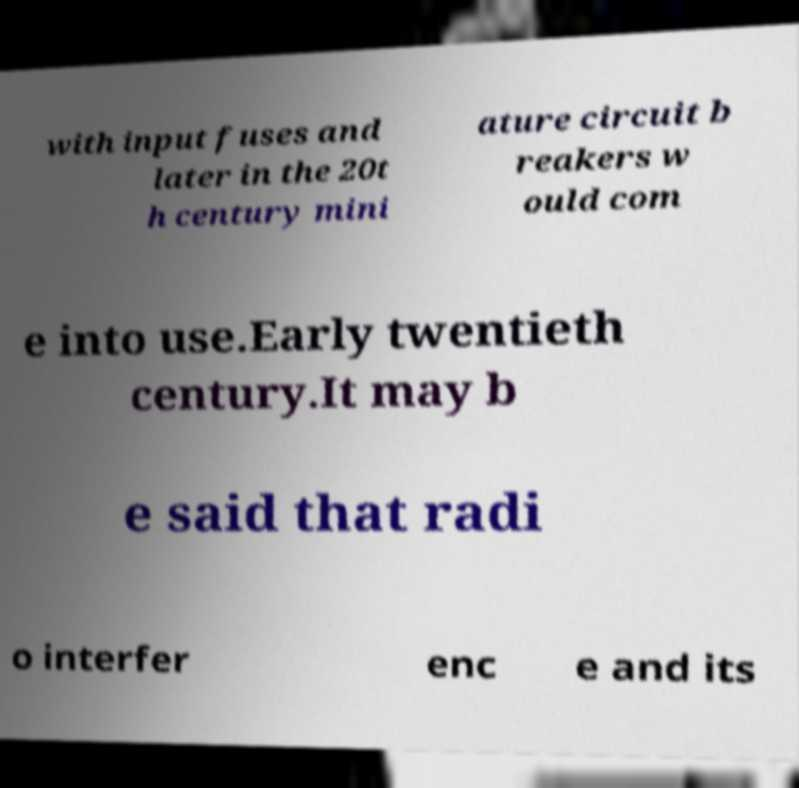Please identify and transcribe the text found in this image. with input fuses and later in the 20t h century mini ature circuit b reakers w ould com e into use.Early twentieth century.It may b e said that radi o interfer enc e and its 